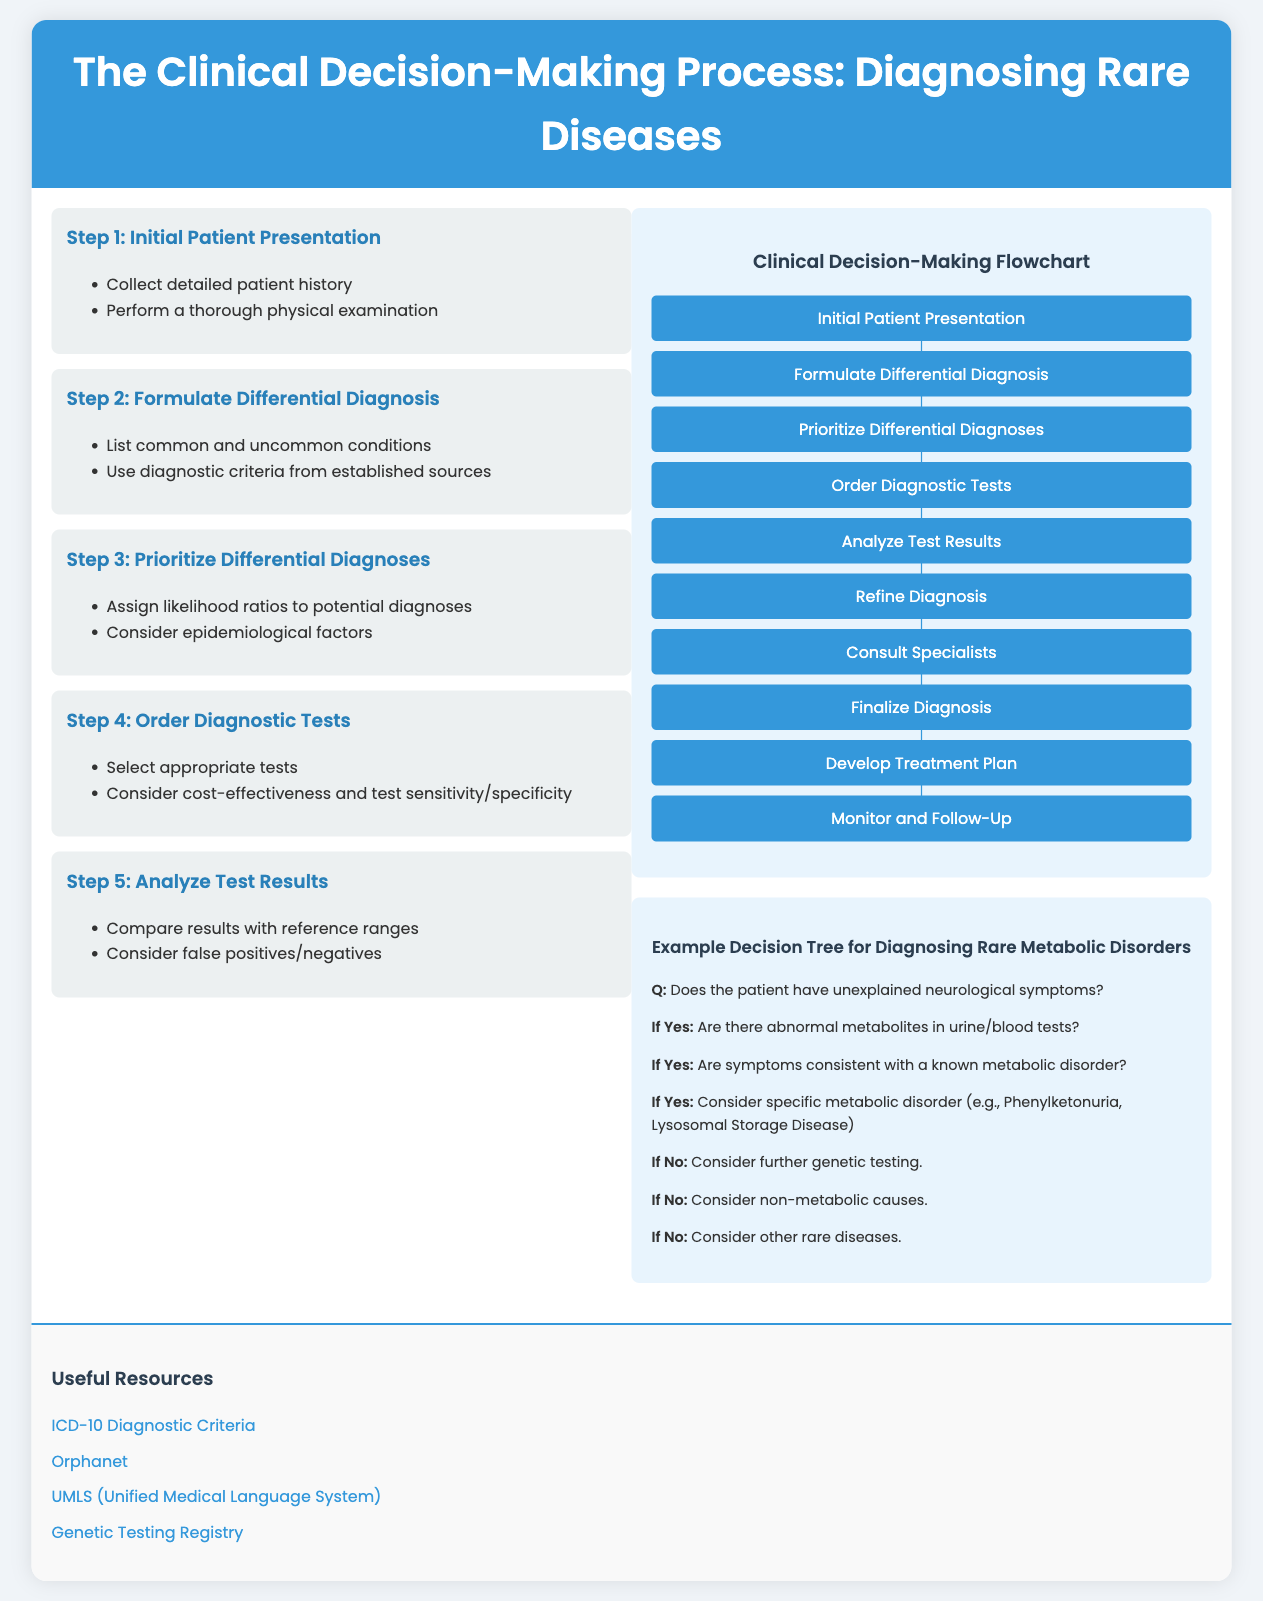What is the first step in the clinical decision-making process? The first step in the process is "Initial Patient Presentation," which involves collecting detailed patient history and performing a physical examination.
Answer: Initial Patient Presentation What is the final step according to the flowchart? The flowchart outlines the steps leading to the final stage, which is "Monitor and Follow-Up."
Answer: Monitor and Follow-Up How many steps are listed in the clinical decision-making flowchart? The flowchart enumerates a series of steps totaling ten from initial presentation to follow-up.
Answer: 10 What condition should be considered if the patient has unexplained neurological symptoms and abnormal metabolites? In this scenario, the decision tree suggests evaluating for specific metabolic disorders like Phenylketonuria or Lysosomal Storage Disease.
Answer: Specific metabolic disorder Which resource provides diagnostic criteria? The document includes a link to an external site that offers diagnostic criteria, specifically the “ICD-10 Diagnostic Criteria.”
Answer: ICD-10 Diagnostic Criteria What type of testing is suggested if abnormal metabolites are not found? The decision tree suggests considering further genetic testing if there are no abnormal metabolites in the tests.
Answer: Further genetic testing What should be prioritized after formulating a differential diagnosis? After formulating a differential diagnosis, the next step is to prioritize differential diagnoses based on likelihood ratios and epidemiological factors.
Answer: Prioritize differential diagnoses What is the background color of the document's body? The background color is specified in the style as a light shade #f0f4f8.
Answer: #f0f4f8 What type of diseases does the decision tree focus on for diagnosis? The decision tree is specifically aimed at diagnosing rare metabolic disorders.
Answer: Rare metabolic disorders 